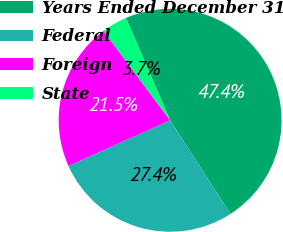Convert chart to OTSL. <chart><loc_0><loc_0><loc_500><loc_500><pie_chart><fcel>Years Ended December 31<fcel>Federal<fcel>Foreign<fcel>State<nl><fcel>47.38%<fcel>27.4%<fcel>21.53%<fcel>3.69%<nl></chart> 